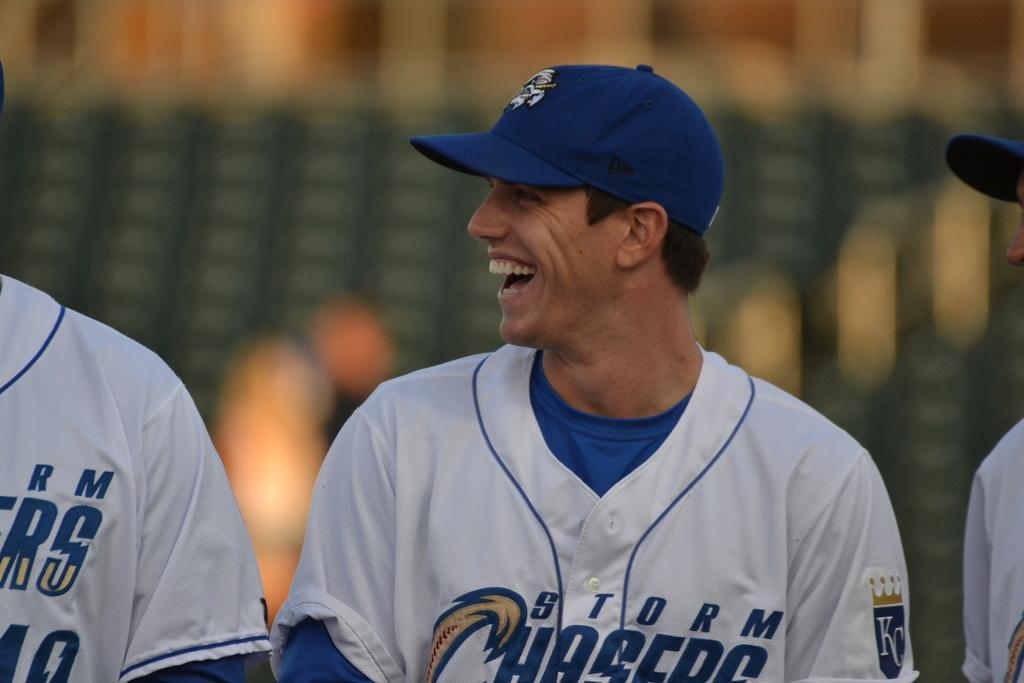What team does the man play baseball for?
Provide a succinct answer. Storm chasers. What's the top word on his jersey?
Keep it short and to the point. Storm. 